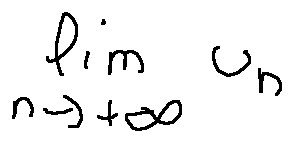Convert formula to latex. <formula><loc_0><loc_0><loc_500><loc_500>\lim \lim i t s _ { n \rightarrow + \infty } u _ { n }</formula> 